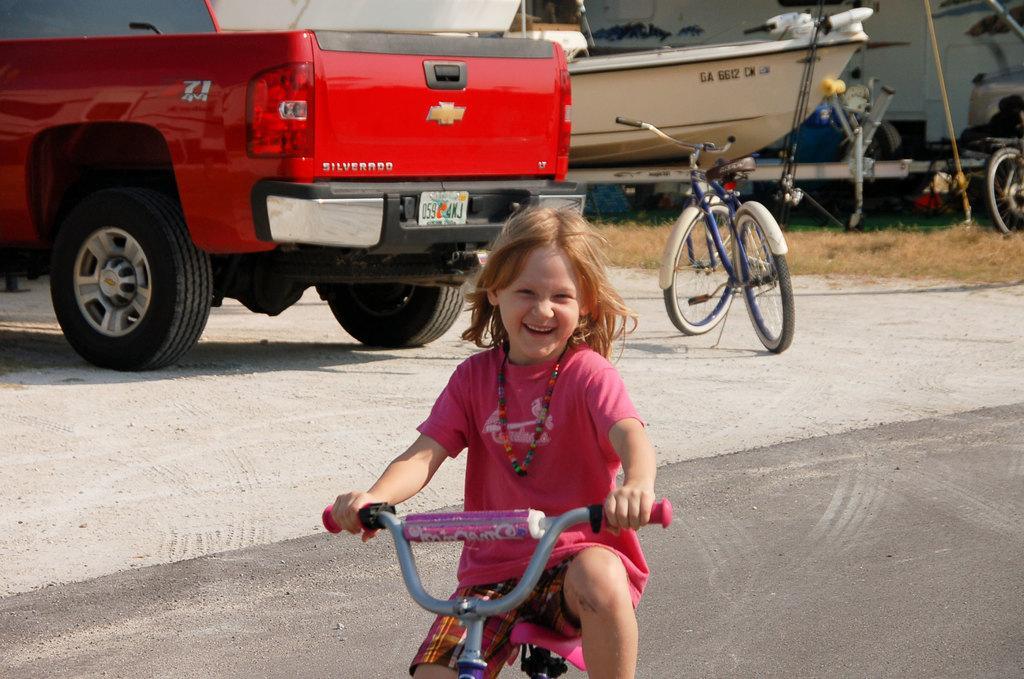How would you summarize this image in a sentence or two? In this image I can see a girl is cycling a cycle, I can also see a smile on her face. In the background I can see few more cycles and few vehicles. 